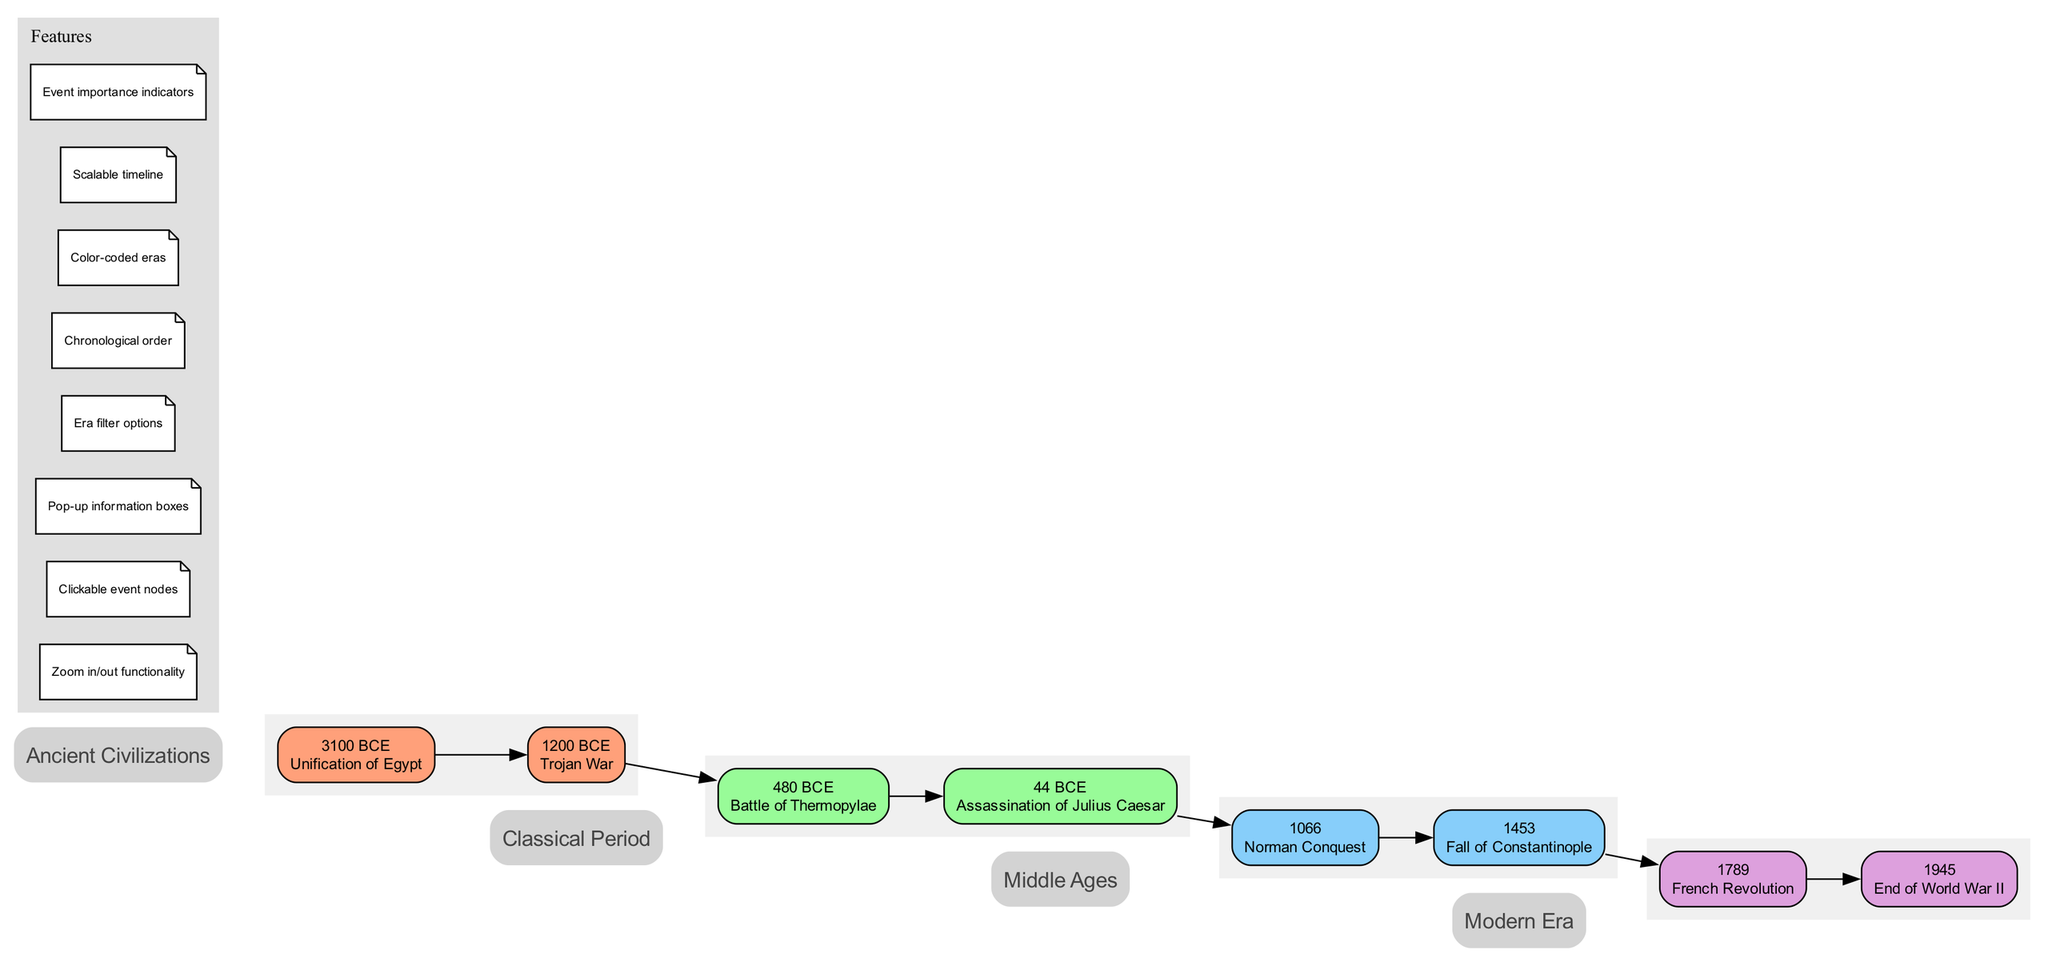What is the earliest event listed in the timeline? The diagram lists events in chronological order. The earliest event is the "Unification of Egypt" in "3100 BCE."
Answer: Unification of Egypt How many events are under the Middle Ages era? The diagram shows a total of two events listed under the "Middle Ages" era: "Norman Conquest" and "Fall of Constantinople."
Answer: 2 Which era follows the Classical Period? Looking at the timeline, the era that follows "Classical Period" is "Middle Ages." The eras are arranged sequentially.
Answer: Middle Ages What significant battle occurred in 480 BCE? The timeline displays "Battle of Thermopylae" as the event that occurred in "480 BCE."
Answer: Battle of Thermopylae Which event marks the end of the Byzantine Empire? The timeline indicates that the "Fall of Constantinople" in "1453" is the event marking the end of the Byzantine Empire.
Answer: Fall of Constantinople How many eras are presented in the timeline? Observing the structure of the diagram, there are four distinct eras presented: "Ancient Civilizations," "Classical Period," "Middle Ages," and "Modern Era."
Answer: 4 What visual indicator shows the importance of events? The diagram includes "Event importance indicators" as part of its features displayed in the legend, indicating a visual way to signify the importance of events.
Answer: Event importance indicators What year did the French Revolution start? The event "French Revolution" is marked in the timeline as occurring in "1789."
Answer: 1789 Which feature allows users to view events in greater detail? The diagram specifies that "Clickable event nodes" allow users to access more detailed information about individual events when using the interface.
Answer: Clickable event nodes 